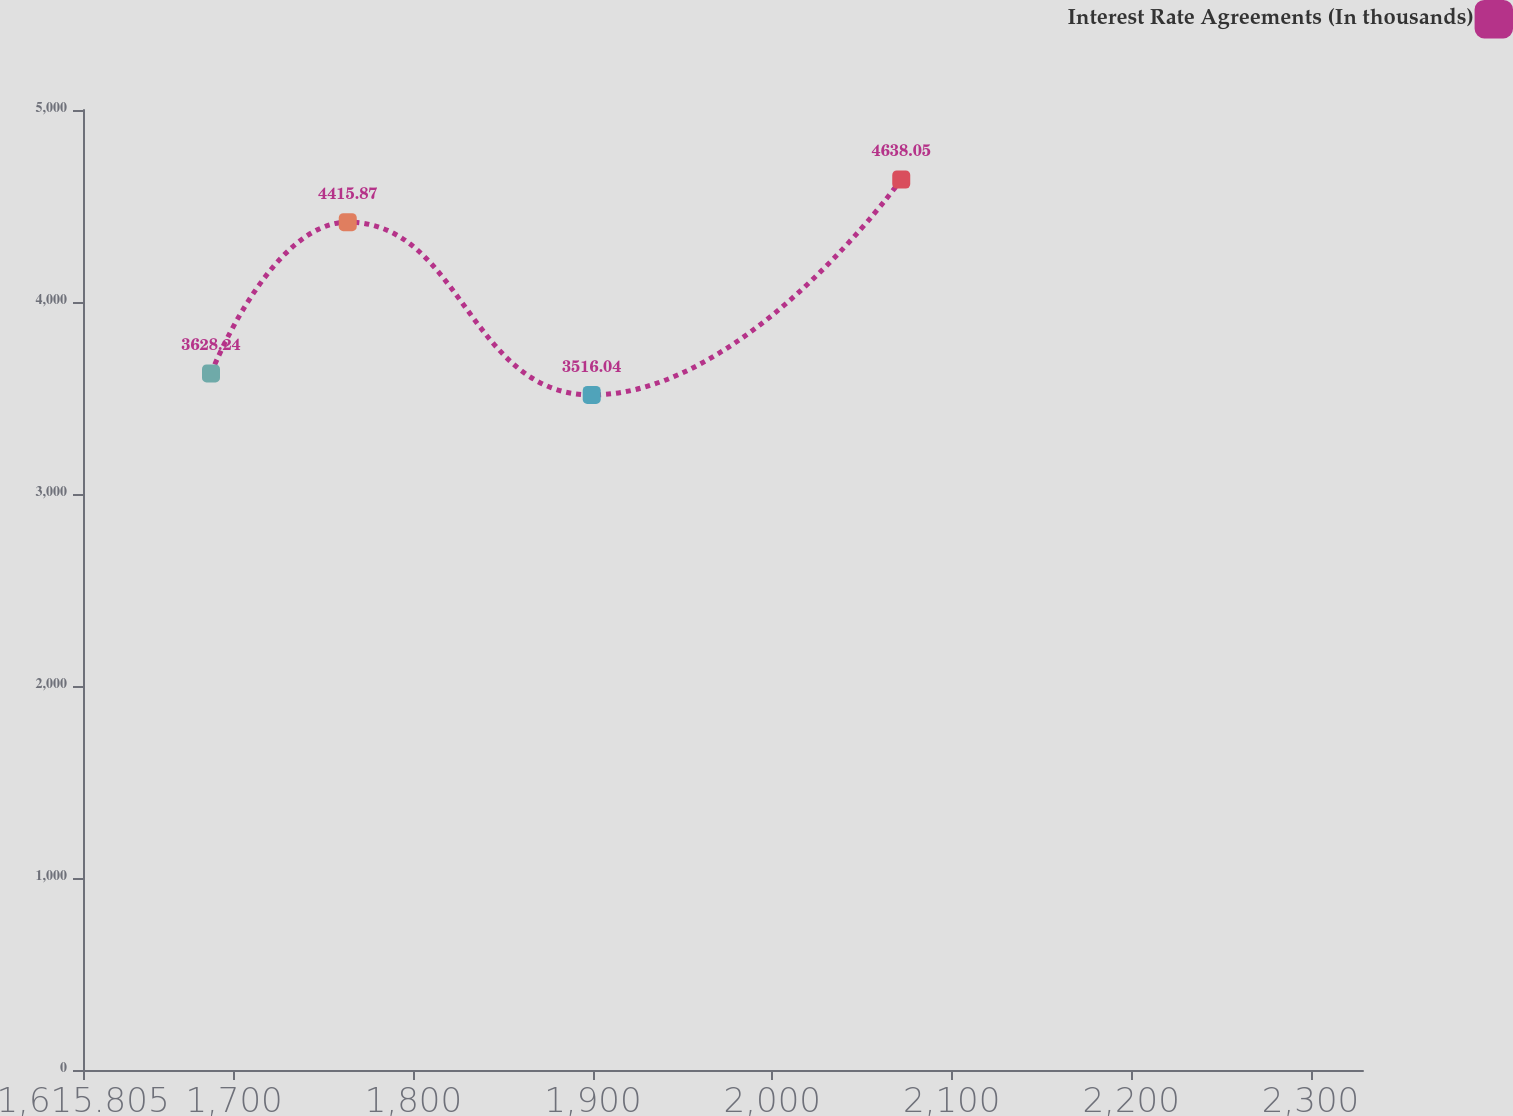Convert chart. <chart><loc_0><loc_0><loc_500><loc_500><line_chart><ecel><fcel>Interest Rate Agreements (In thousands)<nl><fcel>1687.15<fcel>3628.24<nl><fcel>1763.38<fcel>4415.87<nl><fcel>1899.35<fcel>3516.04<nl><fcel>2071.88<fcel>4638.05<nl><fcel>2400.6<fcel>3747.42<nl></chart> 